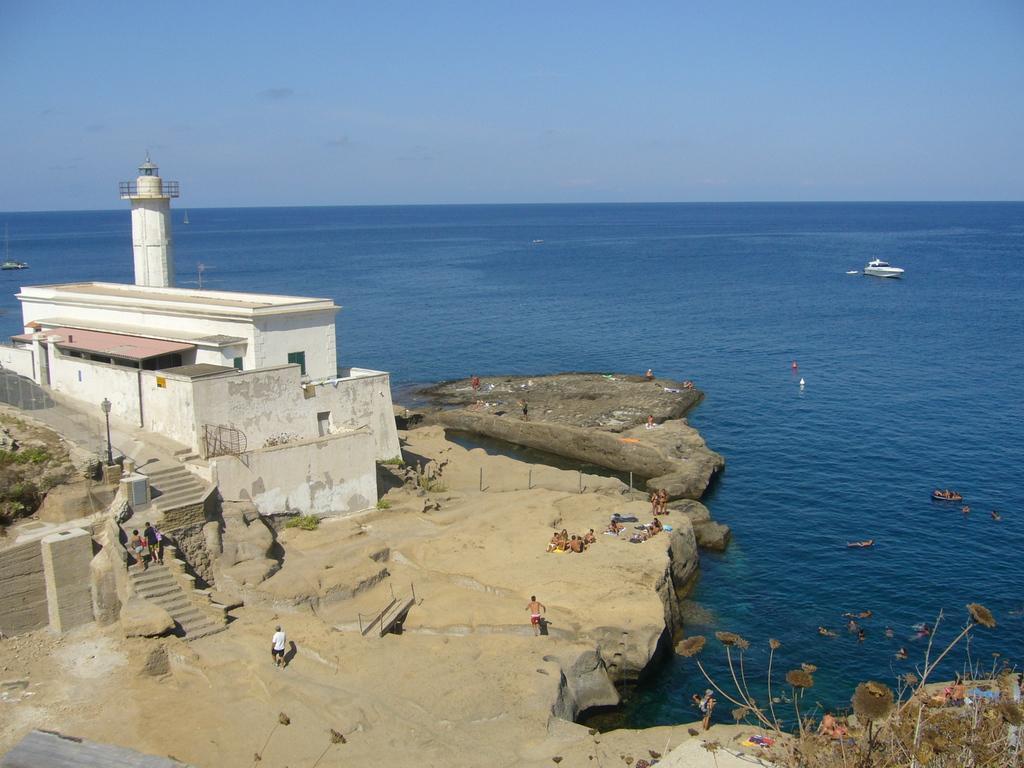Please provide a concise description of this image. In the image i can see a water,house,person's,steps,grass,stones,plants,boat and in the background i can see the sky. 